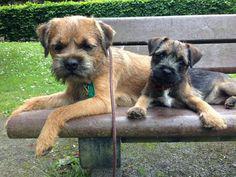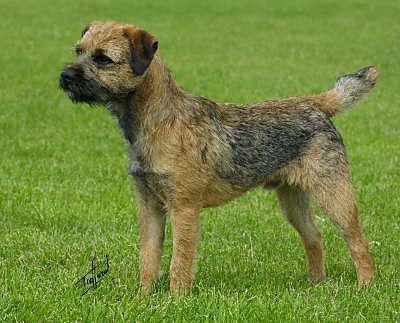The first image is the image on the left, the second image is the image on the right. Given the left and right images, does the statement "The left and right image contains the same number of dogs standing in the grass." hold true? Answer yes or no. No. The first image is the image on the left, the second image is the image on the right. Given the left and right images, does the statement "The right image contains one dog standing with its head and body in profile turned leftward, with all paws on the ground, its mouth closed, and its tail straight and extended." hold true? Answer yes or no. Yes. 